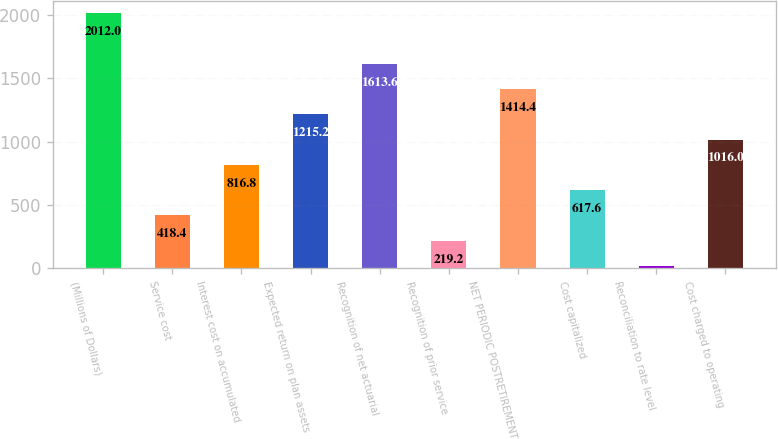<chart> <loc_0><loc_0><loc_500><loc_500><bar_chart><fcel>(Millions of Dollars)<fcel>Service cost<fcel>Interest cost on accumulated<fcel>Expected return on plan assets<fcel>Recognition of net actuarial<fcel>Recognition of prior service<fcel>NET PERIODIC POSTRETIREMENT<fcel>Cost capitalized<fcel>Reconciliation to rate level<fcel>Cost charged to operating<nl><fcel>2012<fcel>418.4<fcel>816.8<fcel>1215.2<fcel>1613.6<fcel>219.2<fcel>1414.4<fcel>617.6<fcel>20<fcel>1016<nl></chart> 